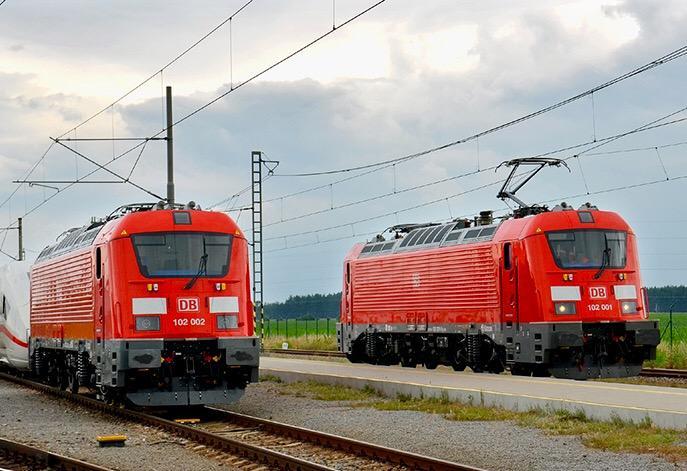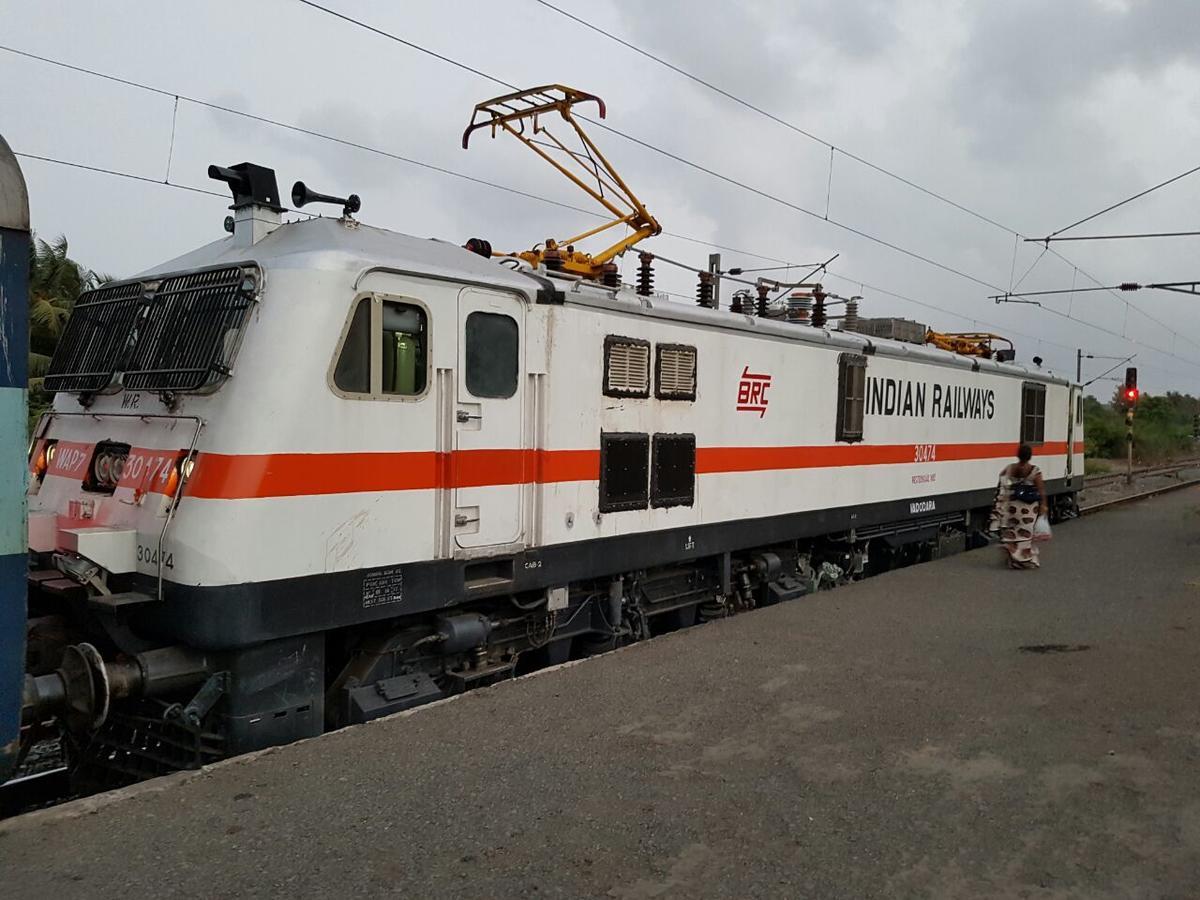The first image is the image on the left, the second image is the image on the right. Assess this claim about the two images: "Right image shows a white train with a red stripe only and an angled front.". Correct or not? Answer yes or no. Yes. The first image is the image on the left, the second image is the image on the right. Considering the images on both sides, is "One train is white with a single red horizontal stripe around the body." valid? Answer yes or no. Yes. 